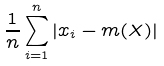Convert formula to latex. <formula><loc_0><loc_0><loc_500><loc_500>\frac { 1 } { n } \sum _ { i = 1 } ^ { n } | x _ { i } - m ( X ) |</formula> 